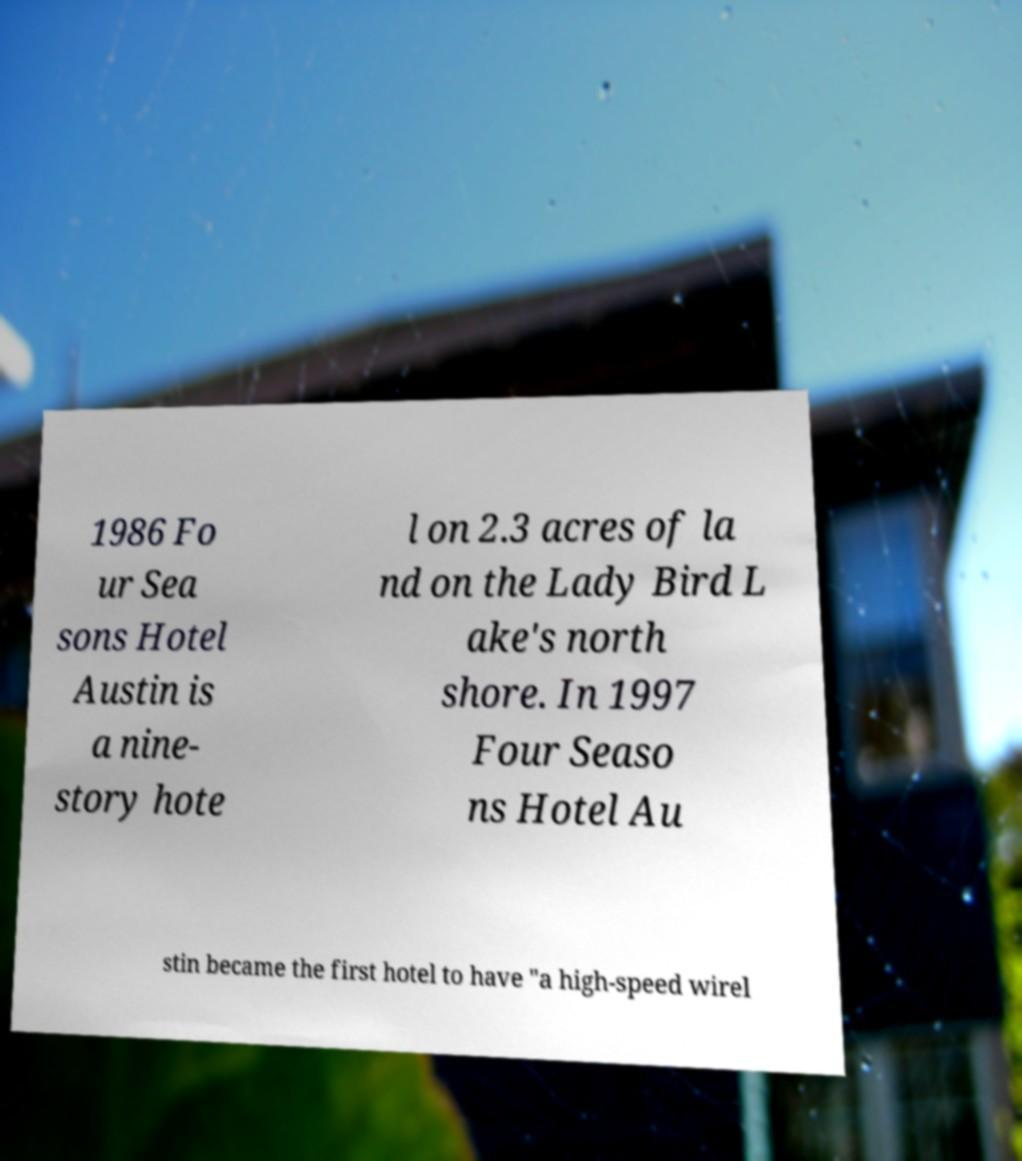I need the written content from this picture converted into text. Can you do that? 1986 Fo ur Sea sons Hotel Austin is a nine- story hote l on 2.3 acres of la nd on the Lady Bird L ake's north shore. In 1997 Four Seaso ns Hotel Au stin became the first hotel to have "a high-speed wirel 